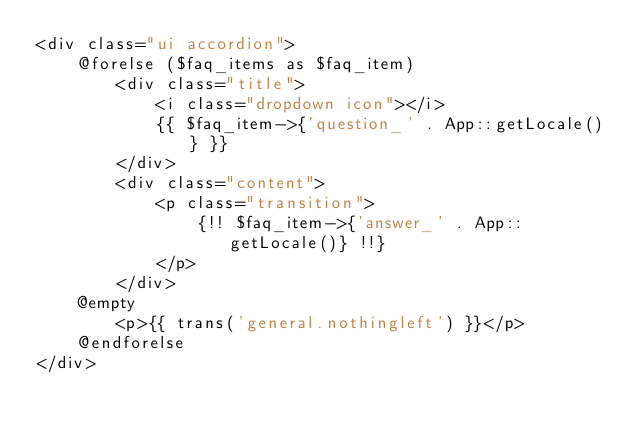<code> <loc_0><loc_0><loc_500><loc_500><_PHP_><div class="ui accordion">
    @forelse ($faq_items as $faq_item)
        <div class="title">
            <i class="dropdown icon"></i>
            {{ $faq_item->{'question_' . App::getLocale()} }}
        </div>
        <div class="content">
            <p class="transition">
                {!! $faq_item->{'answer_' . App::getLocale()} !!}
            </p>
        </div>
    @empty
        <p>{{ trans('general.nothingleft') }}</p>
    @endforelse
</div></code> 